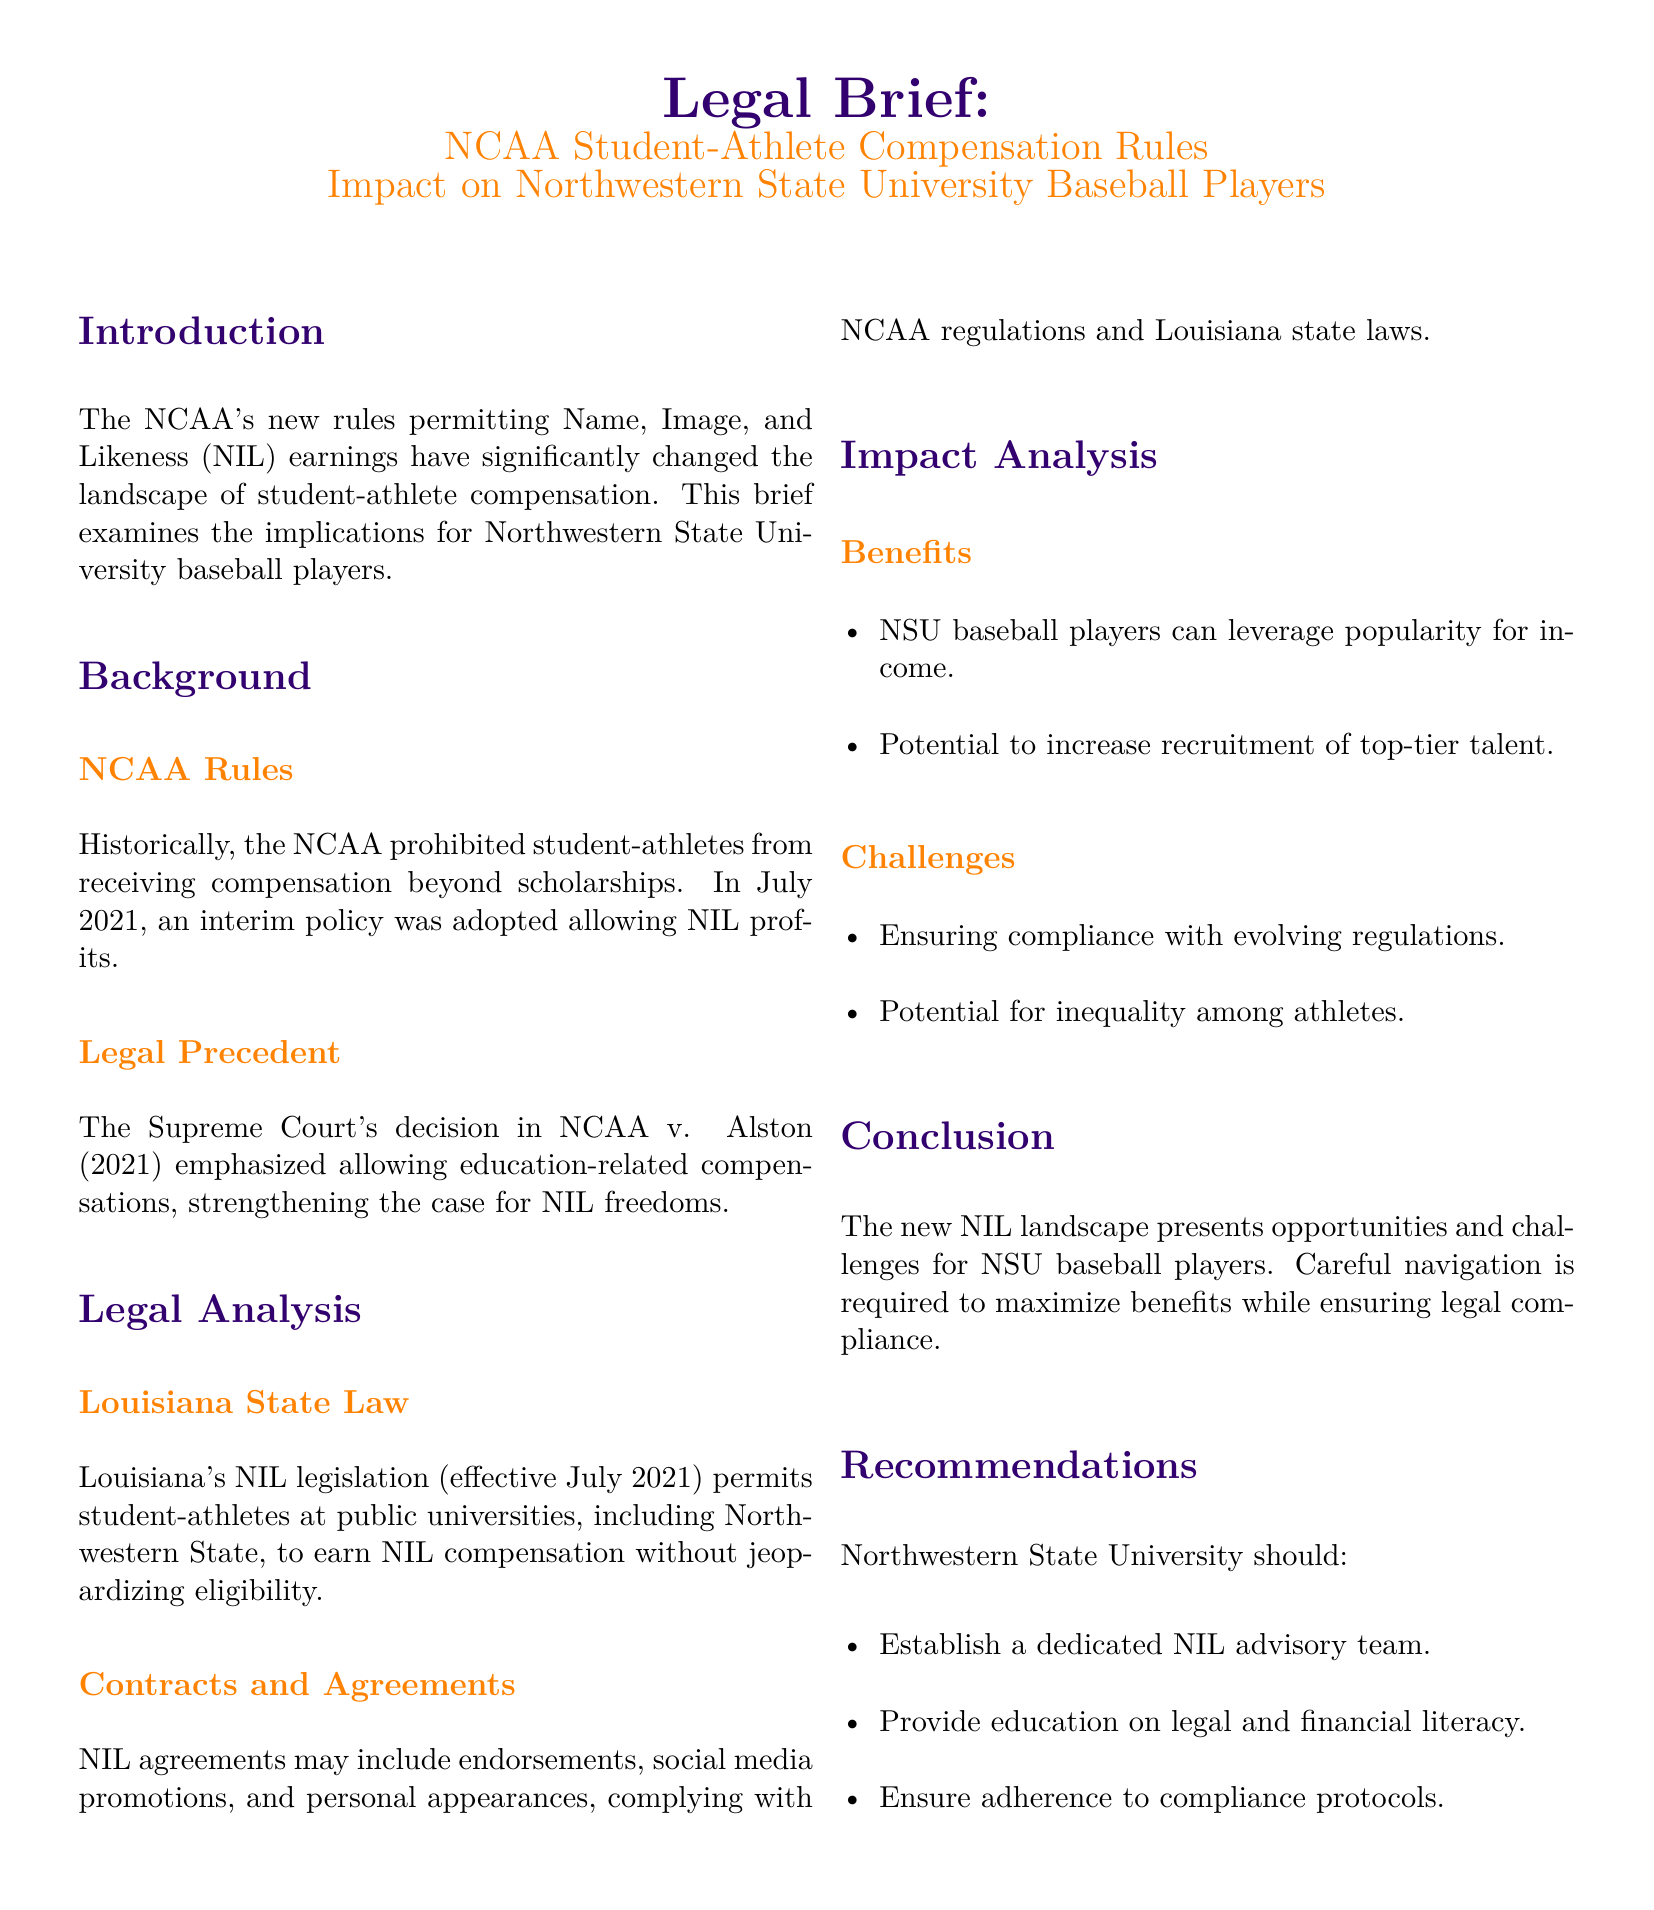What year did the NCAA adopt the interim policy for NIL profits? The document states that the NCAA adopted the interim policy in July 2021.
Answer: July 2021 What significant court case is mentioned in the brief? The legal precedent highlighted in the document refers to NCAA v. Alston.
Answer: NCAA v. Alston What does NIL stand for? The abbreviation NIL stands for Name, Image, and Likeness, as explained in the introduction.
Answer: Name, Image, and Likeness What are two types of agreements mentioned that student-athletes can enter? The document notes that NIL agreements may include endorsements and social media promotions.
Answer: endorsements, social media promotions What legislative action in Louisiana affects student-athletes at public universities? The brief indicates that Louisiana's NIL legislation permits student-athletes to earn NIL compensation without losing eligibility.
Answer: NIL legislation What is a potential benefit for NSU baseball players mentioned? The document states that NSU baseball players can leverage popularity for income as a benefit under the new rules.
Answer: leverage popularity for income What is one of the challenges for NSU baseball players regarding NIL? The brief identifies ensuring compliance with evolving regulations as a challenge for NSU baseball players.
Answer: ensuring compliance with evolving regulations What recommendation is given for Northwestern State University regarding NIL? The document recommends that the university establish a dedicated NIL advisory team for better guidance.
Answer: establish a dedicated NIL advisory team 